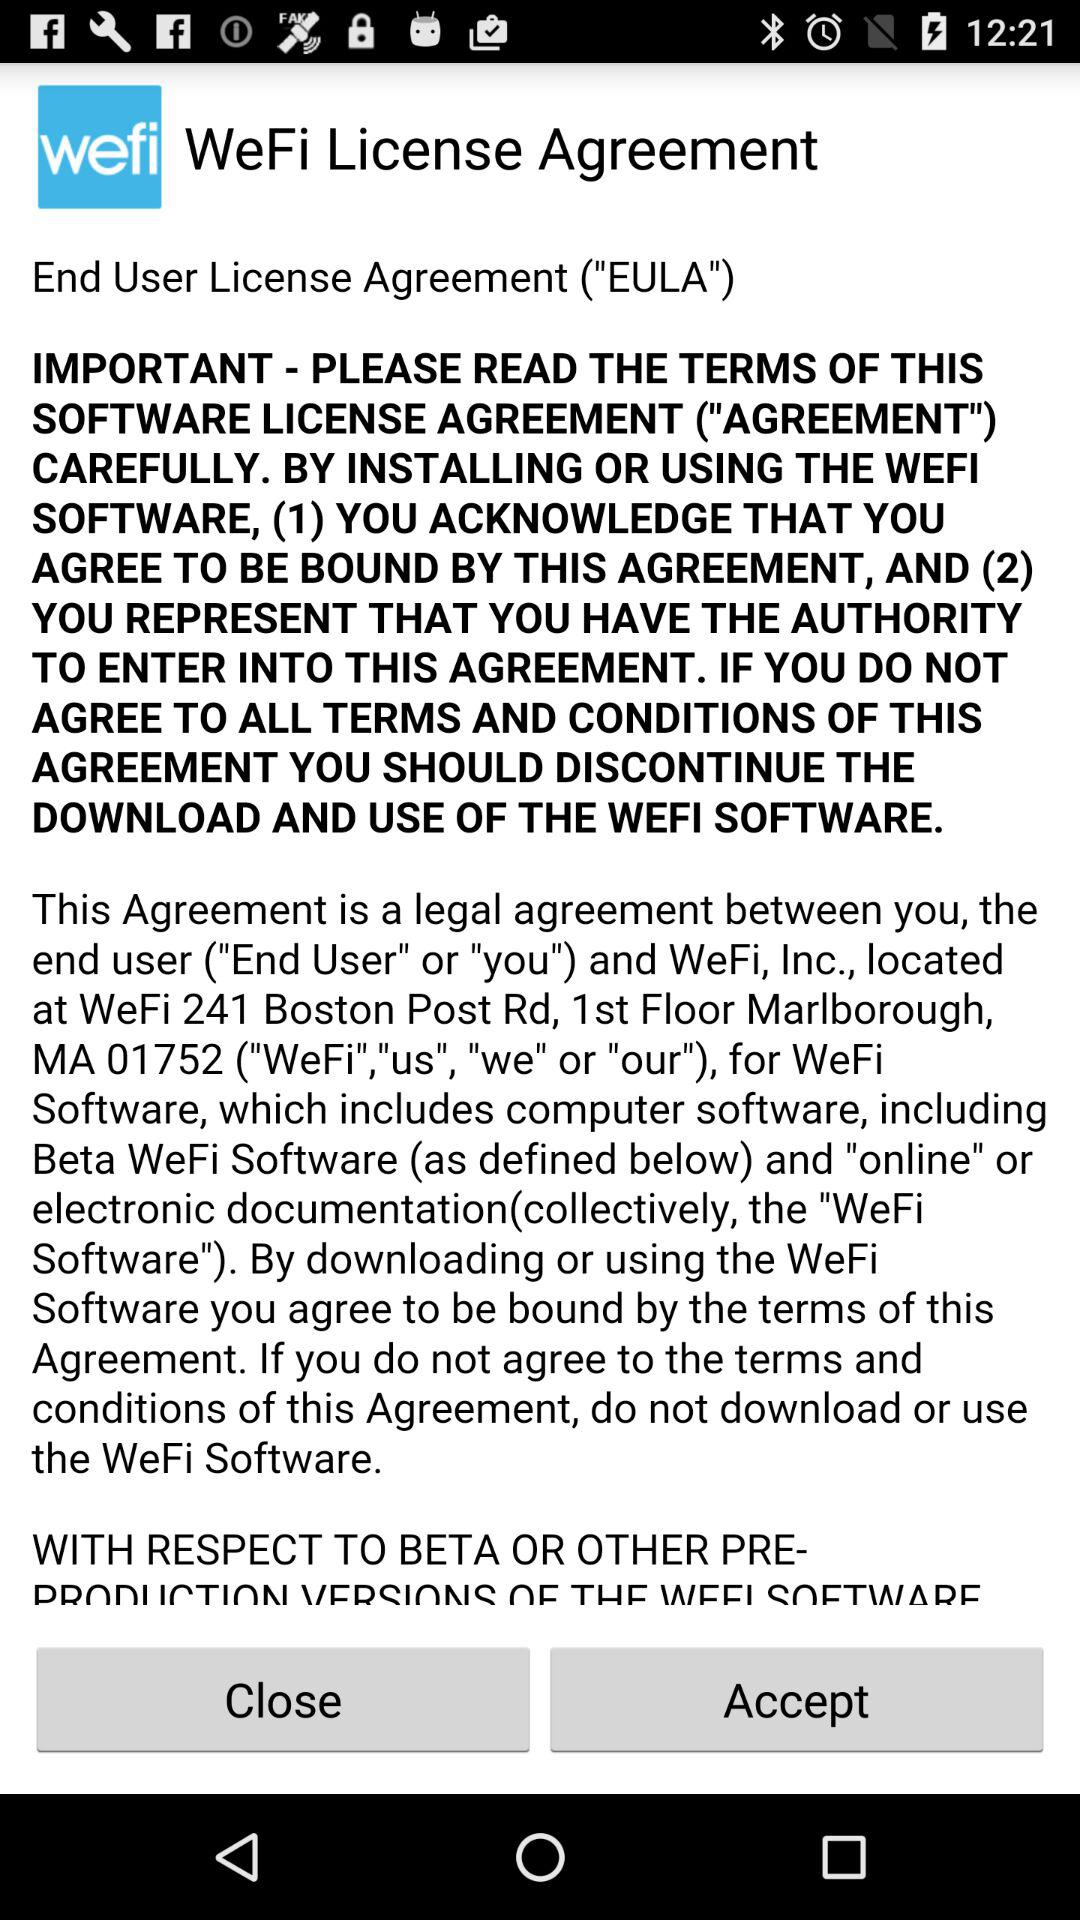Is the agreement accepted?
When the provided information is insufficient, respond with <no answer>. <no answer> 